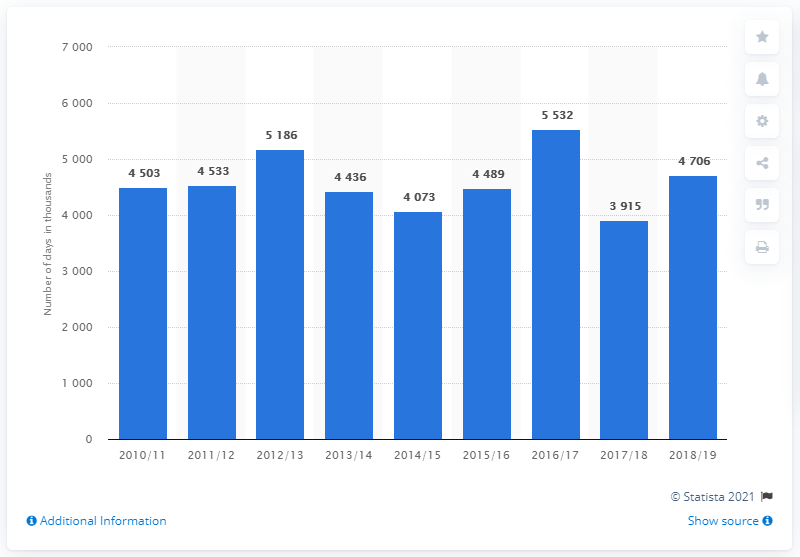Draw attention to some important aspects in this diagram. In the year 2016/17, there was a record high amount of working days lost due to workplace injuries. 